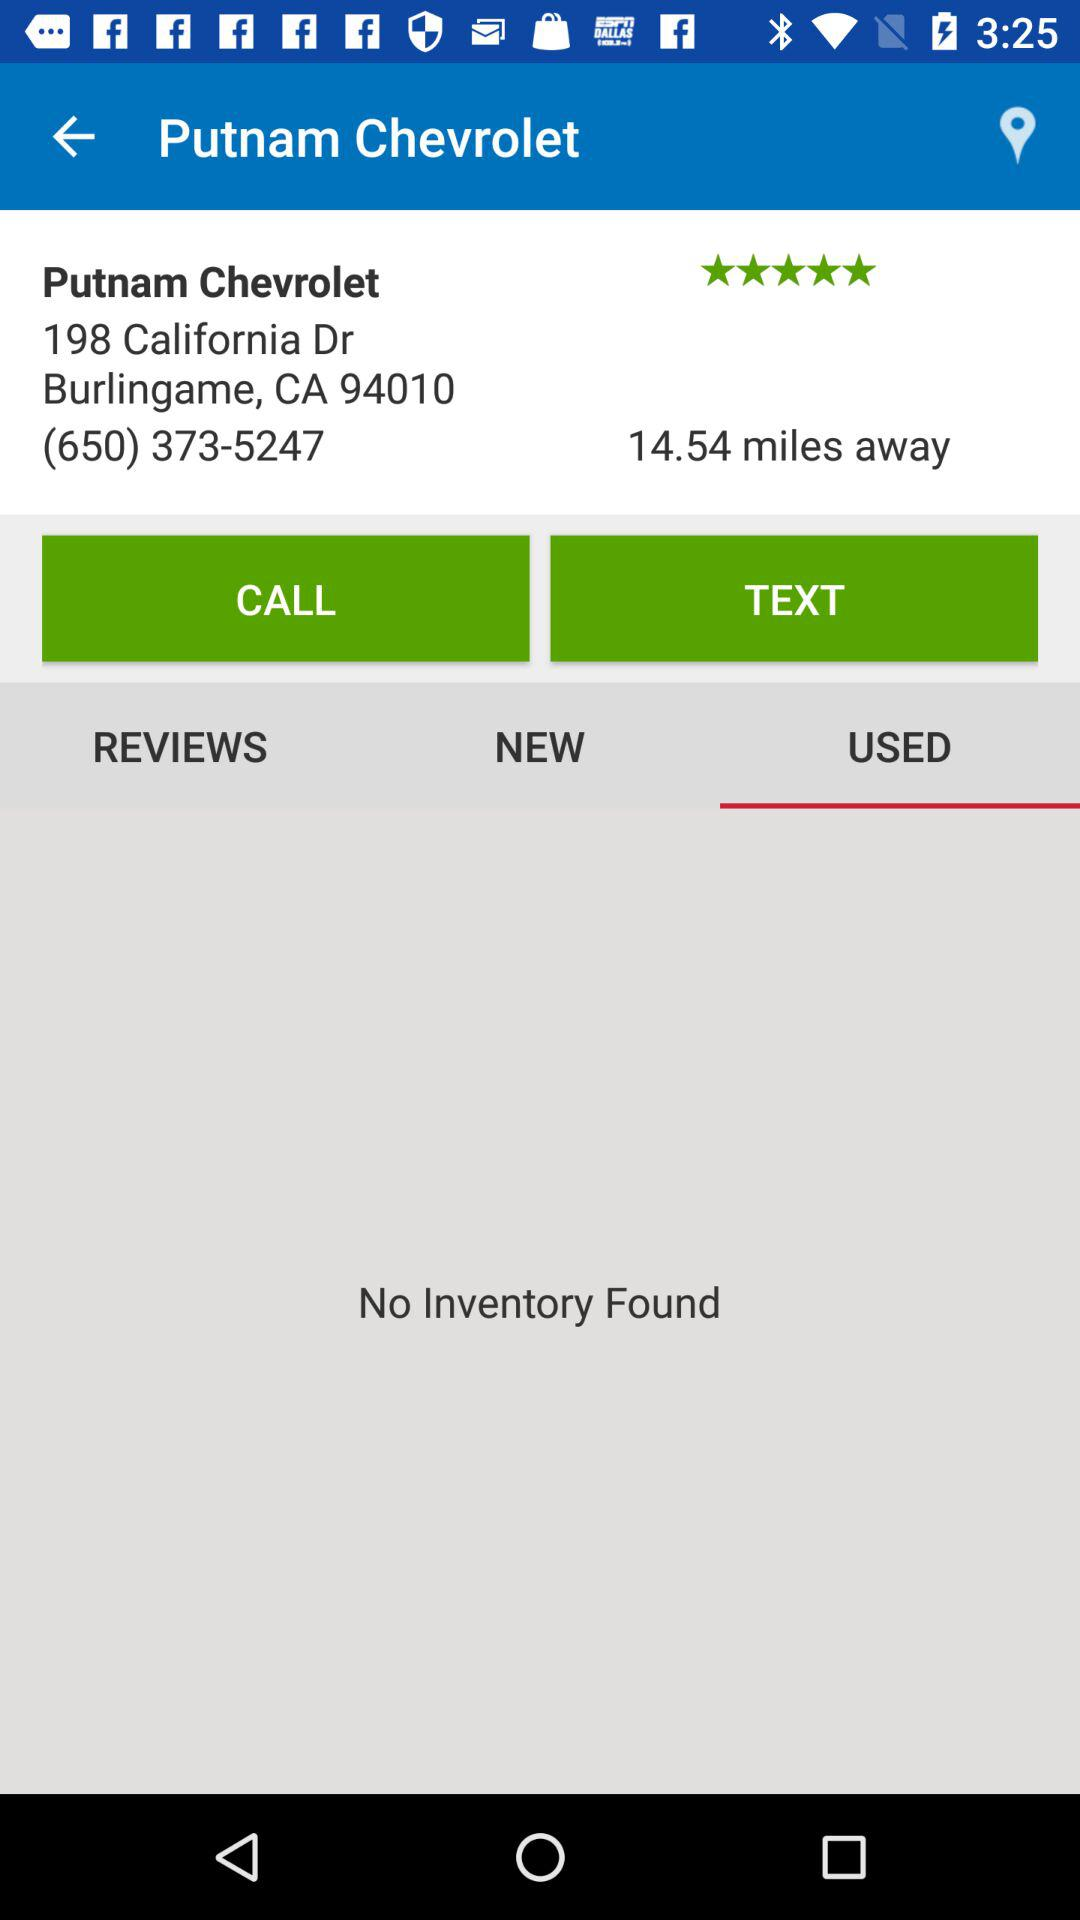What is the selected option? The selected option is "USED". 